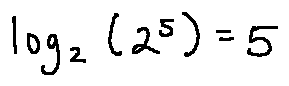Convert formula to latex. <formula><loc_0><loc_0><loc_500><loc_500>\log _ { 2 } ( 2 ^ { 5 } ) = 5</formula> 